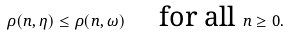<formula> <loc_0><loc_0><loc_500><loc_500>\rho ( n , \eta ) \leq \rho ( n , \omega ) \quad \text { for all } n \geq 0 .</formula> 